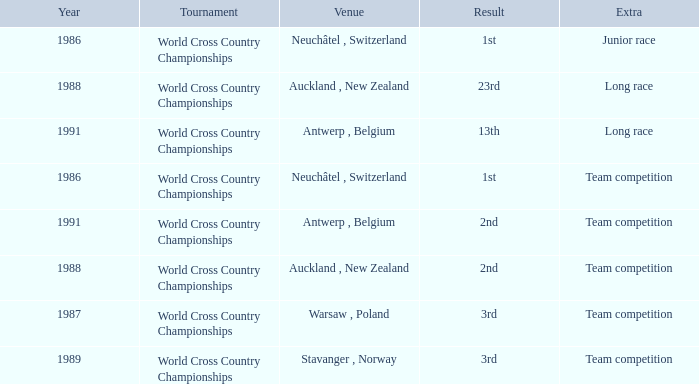Which venue led to a result of 23rd? Auckland , New Zealand. 